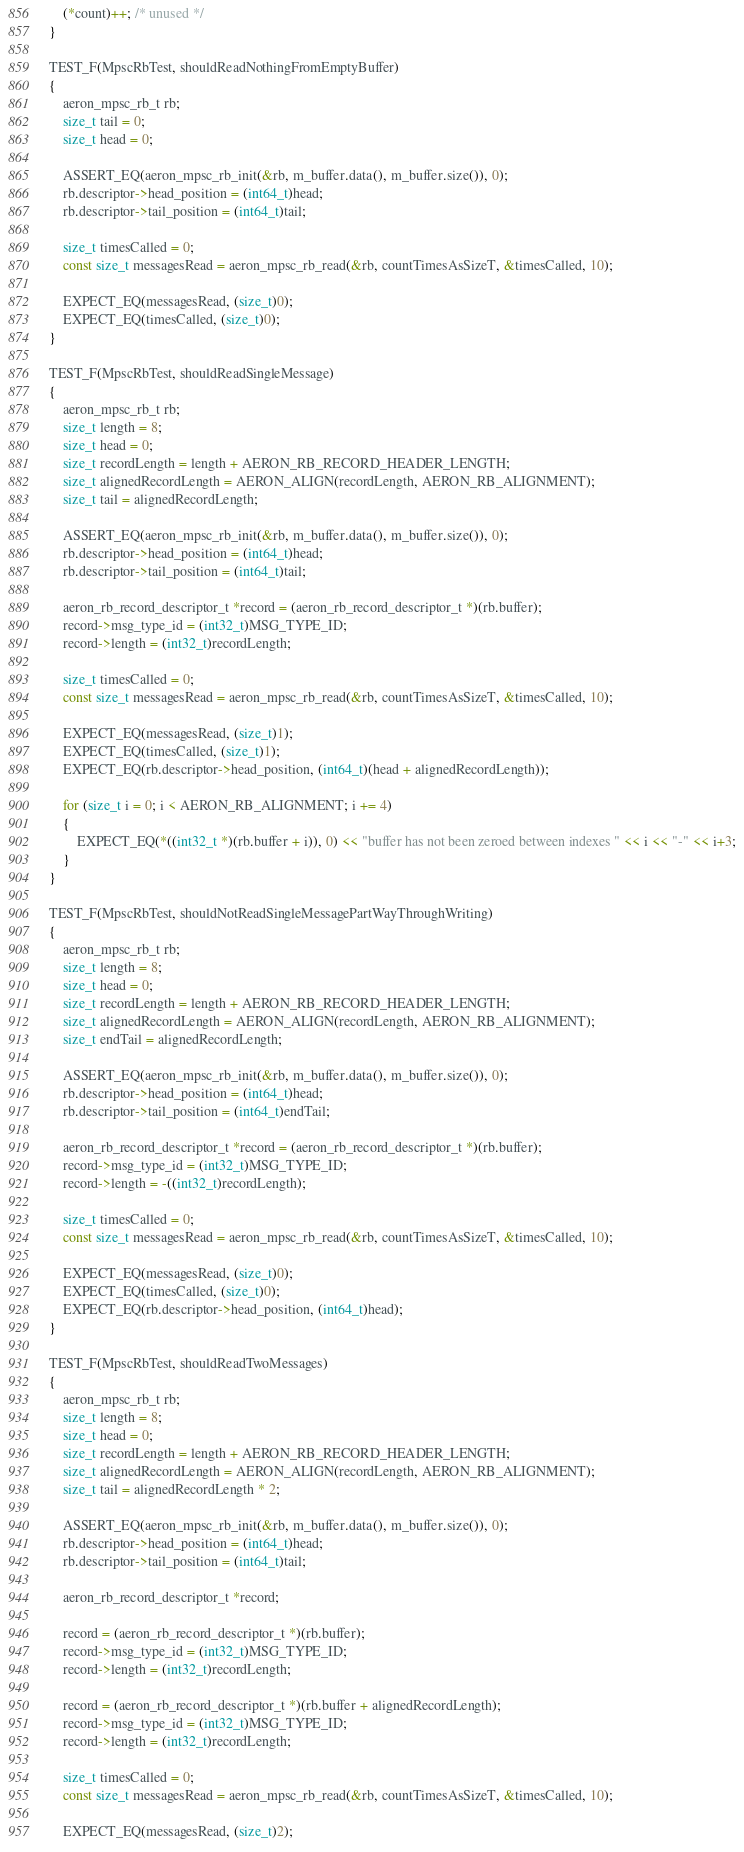Convert code to text. <code><loc_0><loc_0><loc_500><loc_500><_C++_>
    (*count)++; /* unused */
}

TEST_F(MpscRbTest, shouldReadNothingFromEmptyBuffer)
{
    aeron_mpsc_rb_t rb;
    size_t tail = 0;
    size_t head = 0;

    ASSERT_EQ(aeron_mpsc_rb_init(&rb, m_buffer.data(), m_buffer.size()), 0);
    rb.descriptor->head_position = (int64_t)head;
    rb.descriptor->tail_position = (int64_t)tail;

    size_t timesCalled = 0;
    const size_t messagesRead = aeron_mpsc_rb_read(&rb, countTimesAsSizeT, &timesCalled, 10);

    EXPECT_EQ(messagesRead, (size_t)0);
    EXPECT_EQ(timesCalled, (size_t)0);
}

TEST_F(MpscRbTest, shouldReadSingleMessage)
{
    aeron_mpsc_rb_t rb;
    size_t length = 8;
    size_t head = 0;
    size_t recordLength = length + AERON_RB_RECORD_HEADER_LENGTH;
    size_t alignedRecordLength = AERON_ALIGN(recordLength, AERON_RB_ALIGNMENT);
    size_t tail = alignedRecordLength;

    ASSERT_EQ(aeron_mpsc_rb_init(&rb, m_buffer.data(), m_buffer.size()), 0);
    rb.descriptor->head_position = (int64_t)head;
    rb.descriptor->tail_position = (int64_t)tail;

    aeron_rb_record_descriptor_t *record = (aeron_rb_record_descriptor_t *)(rb.buffer);
    record->msg_type_id = (int32_t)MSG_TYPE_ID;
    record->length = (int32_t)recordLength;

    size_t timesCalled = 0;
    const size_t messagesRead = aeron_mpsc_rb_read(&rb, countTimesAsSizeT, &timesCalled, 10);

    EXPECT_EQ(messagesRead, (size_t)1);
    EXPECT_EQ(timesCalled, (size_t)1);
    EXPECT_EQ(rb.descriptor->head_position, (int64_t)(head + alignedRecordLength));

    for (size_t i = 0; i < AERON_RB_ALIGNMENT; i += 4)
    {
        EXPECT_EQ(*((int32_t *)(rb.buffer + i)), 0) << "buffer has not been zeroed between indexes " << i << "-" << i+3;
    }
}

TEST_F(MpscRbTest, shouldNotReadSingleMessagePartWayThroughWriting)
{
    aeron_mpsc_rb_t rb;
    size_t length = 8;
    size_t head = 0;
    size_t recordLength = length + AERON_RB_RECORD_HEADER_LENGTH;
    size_t alignedRecordLength = AERON_ALIGN(recordLength, AERON_RB_ALIGNMENT);
    size_t endTail = alignedRecordLength;

    ASSERT_EQ(aeron_mpsc_rb_init(&rb, m_buffer.data(), m_buffer.size()), 0);
    rb.descriptor->head_position = (int64_t)head;
    rb.descriptor->tail_position = (int64_t)endTail;

    aeron_rb_record_descriptor_t *record = (aeron_rb_record_descriptor_t *)(rb.buffer);
    record->msg_type_id = (int32_t)MSG_TYPE_ID;
    record->length = -((int32_t)recordLength);

    size_t timesCalled = 0;
    const size_t messagesRead = aeron_mpsc_rb_read(&rb, countTimesAsSizeT, &timesCalled, 10);

    EXPECT_EQ(messagesRead, (size_t)0);
    EXPECT_EQ(timesCalled, (size_t)0);
    EXPECT_EQ(rb.descriptor->head_position, (int64_t)head);
}

TEST_F(MpscRbTest, shouldReadTwoMessages)
{
    aeron_mpsc_rb_t rb;
    size_t length = 8;
    size_t head = 0;
    size_t recordLength = length + AERON_RB_RECORD_HEADER_LENGTH;
    size_t alignedRecordLength = AERON_ALIGN(recordLength, AERON_RB_ALIGNMENT);
    size_t tail = alignedRecordLength * 2;

    ASSERT_EQ(aeron_mpsc_rb_init(&rb, m_buffer.data(), m_buffer.size()), 0);
    rb.descriptor->head_position = (int64_t)head;
    rb.descriptor->tail_position = (int64_t)tail;

    aeron_rb_record_descriptor_t *record;

    record = (aeron_rb_record_descriptor_t *)(rb.buffer);
    record->msg_type_id = (int32_t)MSG_TYPE_ID;
    record->length = (int32_t)recordLength;

    record = (aeron_rb_record_descriptor_t *)(rb.buffer + alignedRecordLength);
    record->msg_type_id = (int32_t)MSG_TYPE_ID;
    record->length = (int32_t)recordLength;

    size_t timesCalled = 0;
    const size_t messagesRead = aeron_mpsc_rb_read(&rb, countTimesAsSizeT, &timesCalled, 10);

    EXPECT_EQ(messagesRead, (size_t)2);</code> 